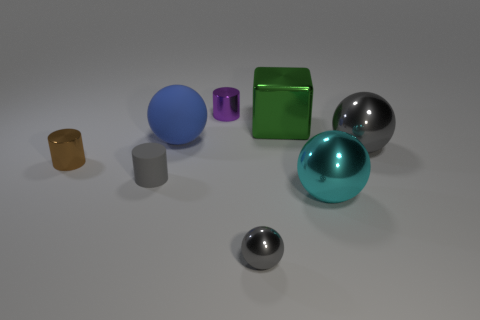Is the number of big metal objects less than the number of small purple matte cubes?
Ensure brevity in your answer.  No. Does the metallic cylinder that is behind the tiny brown object have the same color as the big rubber object?
Your answer should be very brief. No. What number of other metal cylinders have the same size as the brown cylinder?
Provide a short and direct response. 1. Are there any small metal spheres of the same color as the matte sphere?
Your answer should be compact. No. Does the green thing have the same material as the tiny gray cylinder?
Ensure brevity in your answer.  No. What number of green metallic objects have the same shape as the tiny purple metallic thing?
Ensure brevity in your answer.  0. The purple thing that is made of the same material as the big cyan ball is what shape?
Keep it short and to the point. Cylinder. There is a tiny thing behind the gray ball behind the tiny rubber cylinder; what color is it?
Offer a terse response. Purple. Is the color of the big matte sphere the same as the small rubber thing?
Your answer should be very brief. No. What material is the gray object that is left of the large ball that is on the left side of the purple metal cylinder?
Provide a succinct answer. Rubber. 